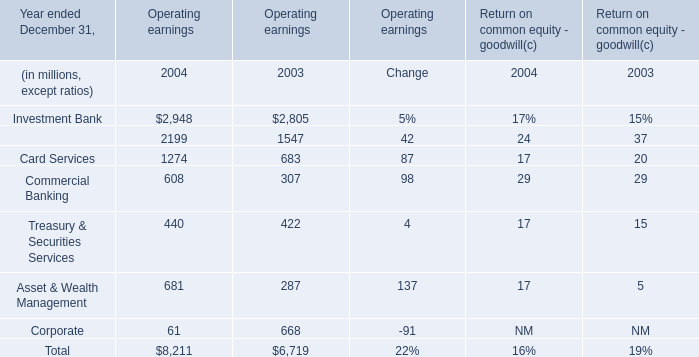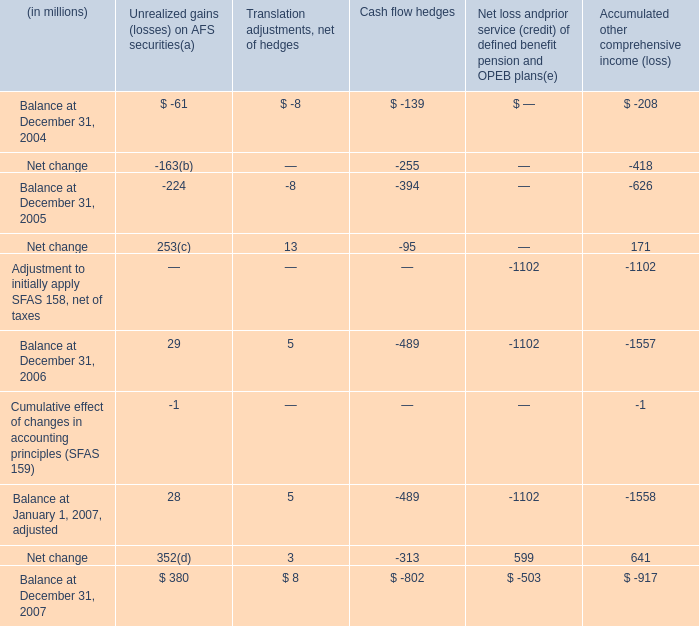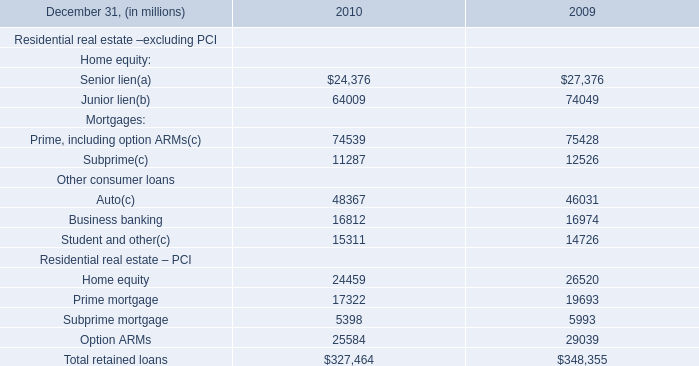What's the average of Home equity Residential real estate – PCI of 2010, and Retail Financial Services of Operating earnings 2003 ? 
Computations: ((24459.0 + 1547.0) / 2)
Answer: 13003.0. 